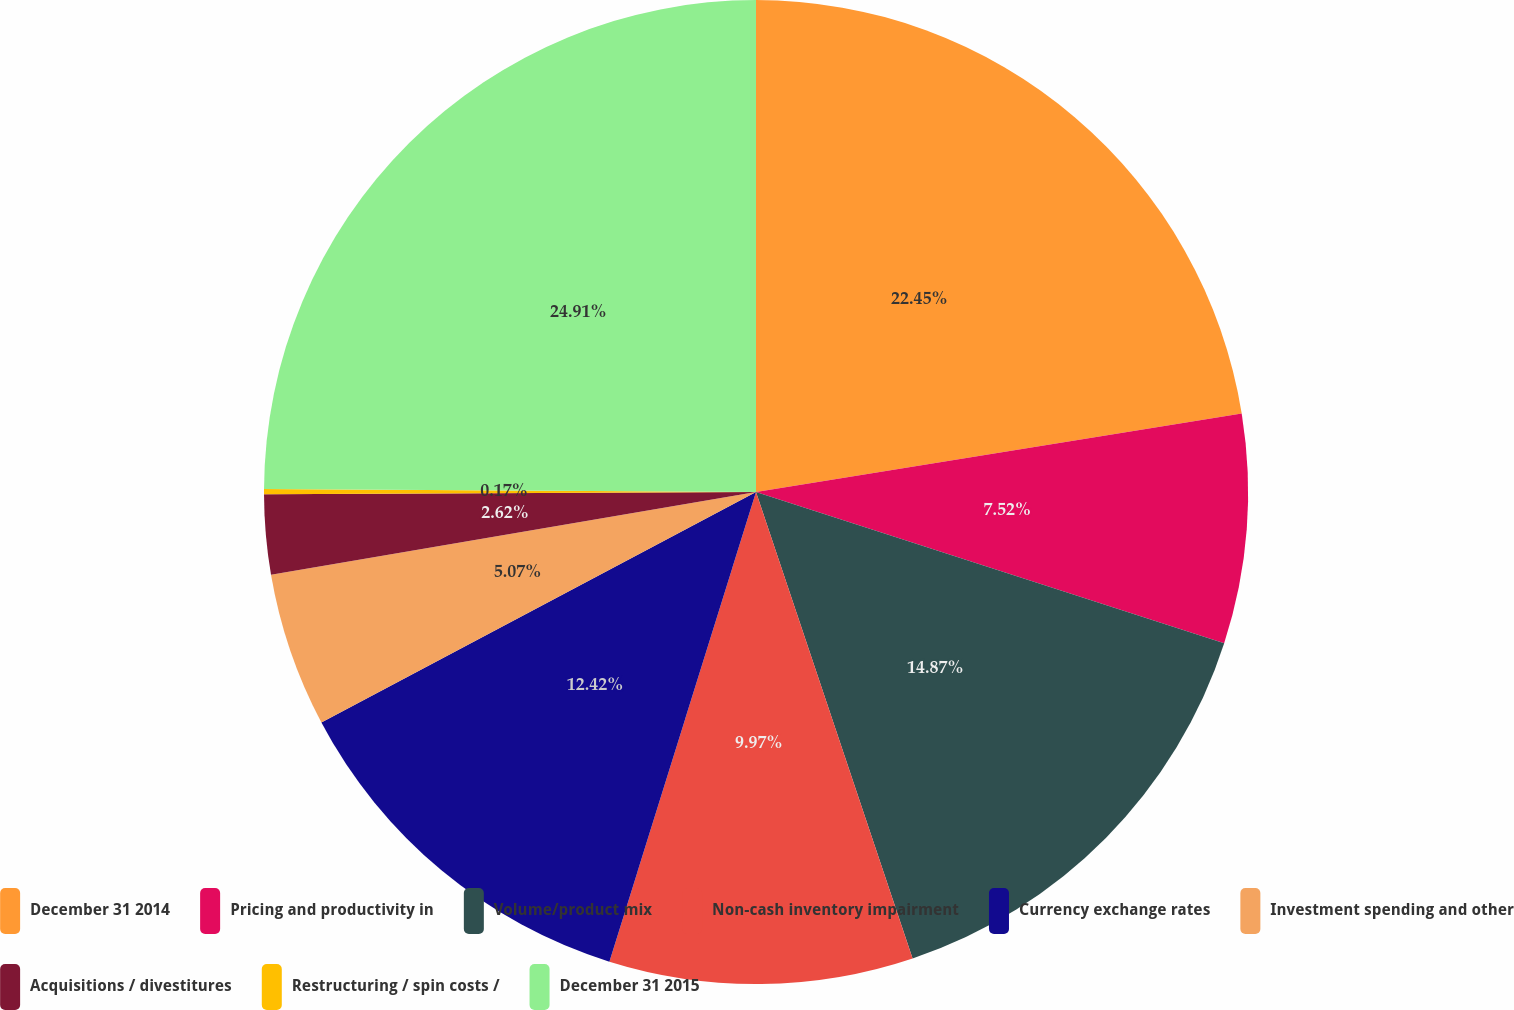<chart> <loc_0><loc_0><loc_500><loc_500><pie_chart><fcel>December 31 2014<fcel>Pricing and productivity in<fcel>Volume/product mix<fcel>Non-cash inventory impairment<fcel>Currency exchange rates<fcel>Investment spending and other<fcel>Acquisitions / divestitures<fcel>Restructuring / spin costs /<fcel>December 31 2015<nl><fcel>22.45%<fcel>7.52%<fcel>14.87%<fcel>9.97%<fcel>12.42%<fcel>5.07%<fcel>2.62%<fcel>0.17%<fcel>24.9%<nl></chart> 